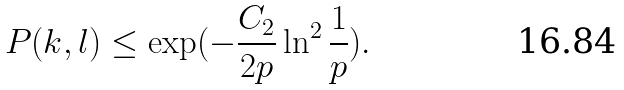<formula> <loc_0><loc_0><loc_500><loc_500>P ( k , l ) \leq \exp ( - \frac { C _ { 2 } } { 2 p } \ln ^ { 2 } \frac { 1 } { p } ) .</formula> 